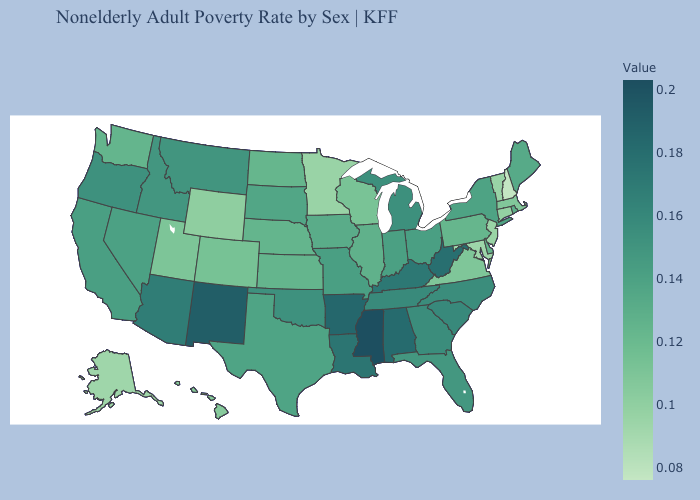Does California have the lowest value in the West?
Keep it brief. No. Among the states that border Vermont , which have the lowest value?
Quick response, please. New Hampshire. Among the states that border North Dakota , which have the lowest value?
Be succinct. Minnesota. Which states have the lowest value in the USA?
Concise answer only. New Hampshire. Among the states that border Alabama , which have the lowest value?
Keep it brief. Florida. 